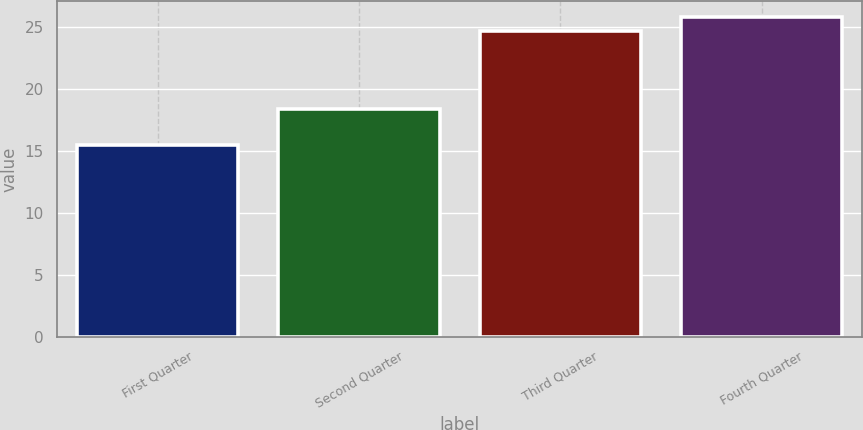Convert chart. <chart><loc_0><loc_0><loc_500><loc_500><bar_chart><fcel>First Quarter<fcel>Second Quarter<fcel>Third Quarter<fcel>Fourth Quarter<nl><fcel>15.48<fcel>18.39<fcel>24.74<fcel>25.8<nl></chart> 